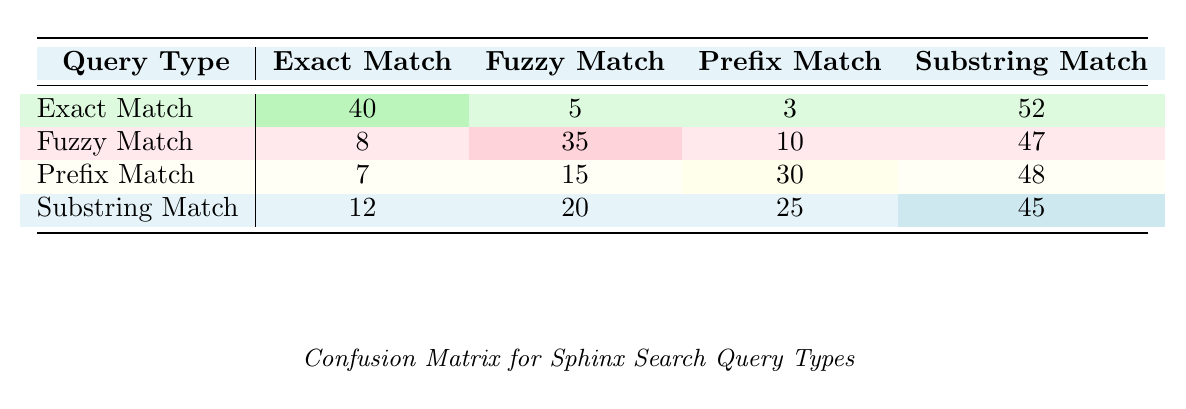What is the True Positive value for Exact Match? According to the table, the True Positive value for Exact Match is listed directly under the Exact Match row. It is explicitly stated as 40.
Answer: 40 What is the False Negative for Fuzzy Match? The table indicates that the False Negative for Fuzzy Match can be found in the corresponding row. The value is directly presented as 10.
Answer: 10 Which query type has the highest True Positive value? By examining the True Positive values for all query types, the values are 40 (Exact Match), 35 (Fuzzy Match), 30 (Prefix Match), and 25 (Substring Match). The highest value is 40 for Exact Match.
Answer: Exact Match What is the total number of True Positives across all query types? To find the total number of True Positives, sum up all the True Positive values: 40 + 35 + 30 + 25 = 130.
Answer: 130 Is the False Positive for Substring Match greater than the False Positive for Prefix Match? The False Positive for Substring Match is 12, while for Prefix Match it is 7. Since 12 is greater than 7, the statement is true.
Answer: Yes What is the difference between the True Positive and False Negative for Prefix Match? For Prefix Match, the True Positive is 30 and the False Negative is 15. Subtracting gives: 30 - 15 = 15.
Answer: 15 What is the average True Positive value across all query types? The True Positive values are 40, 35, 30, and 25. Adding these together yields 130 and dividing by 4 (the number of types) results in an average of 32.5.
Answer: 32.5 Which query type has the lowest True Negative count? The True Negative counts are 52 (Exact Match), 47 (Fuzzy Match), 48 (Prefix Match), and 45 (Substring Match). The lowest value is 45 from Substring Match.
Answer: Substring Match Are there more False Positives than True Negatives in the Fuzzy Match category? The False Positives in the Fuzzy Match category are 8, and the True Negatives are 47. Since 8 is fewer than 47, the statement is false.
Answer: No 